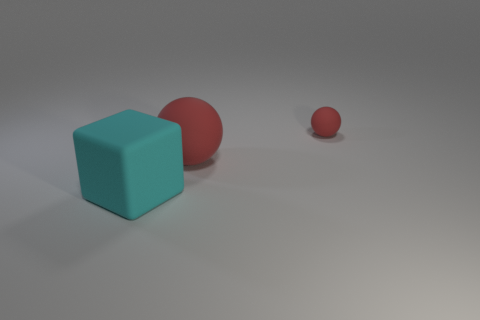The object that is the same size as the cyan matte cube is what color?
Your response must be concise. Red. Do the large object on the right side of the big matte block and the matte cube have the same color?
Keep it short and to the point. No. Is there another yellow sphere made of the same material as the small sphere?
Offer a very short reply. No. There is another rubber object that is the same color as the small matte object; what is its shape?
Your answer should be very brief. Sphere. Are there fewer red balls left of the large red rubber thing than large red cubes?
Your answer should be compact. No. How many big cyan rubber objects are the same shape as the big red rubber object?
Offer a very short reply. 0. What size is the other red object that is made of the same material as the small object?
Provide a short and direct response. Large. Are there an equal number of big matte balls that are in front of the tiny red ball and rubber spheres?
Your answer should be compact. No. Is the color of the big block the same as the small rubber object?
Make the answer very short. No. There is a red matte object on the left side of the small matte object; is its shape the same as the red thing that is behind the big red ball?
Make the answer very short. Yes. 